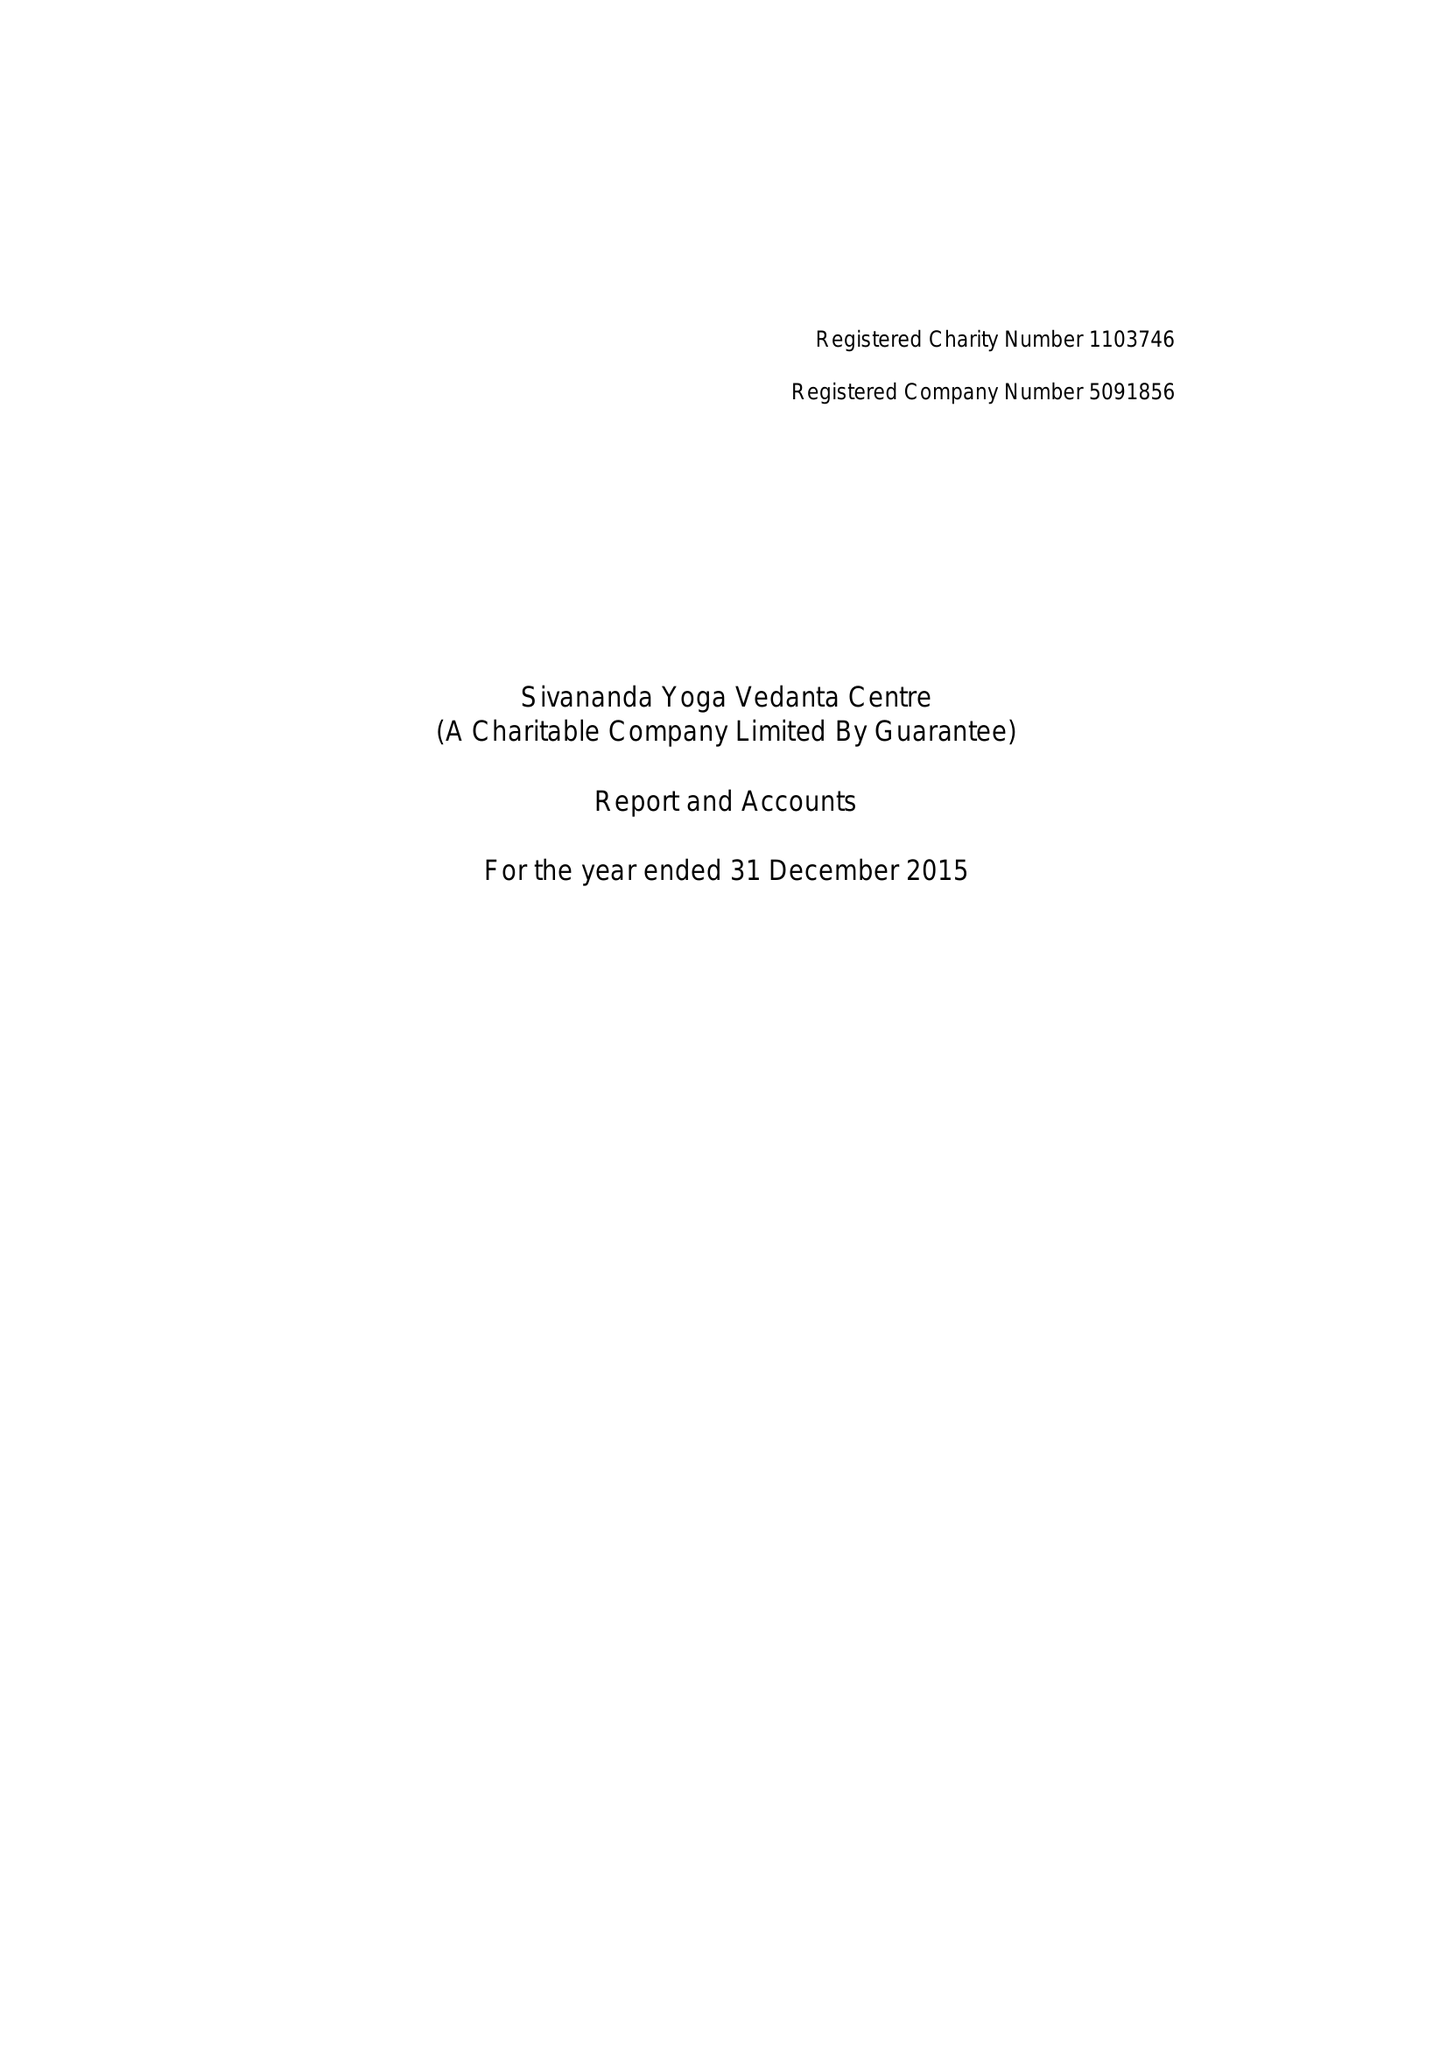What is the value for the address__postcode?
Answer the question using a single word or phrase. SW15 1AZ 